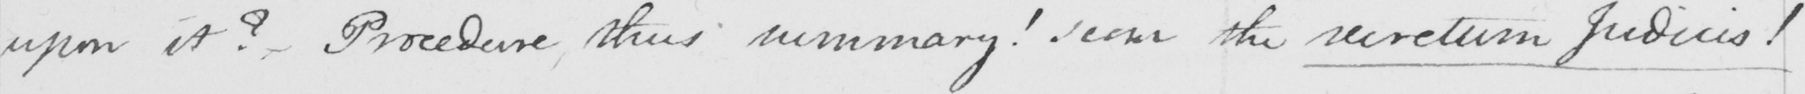What text is written in this handwritten line? upon it ?  Procedure , thus summary !  score the secretum Judicis ! 